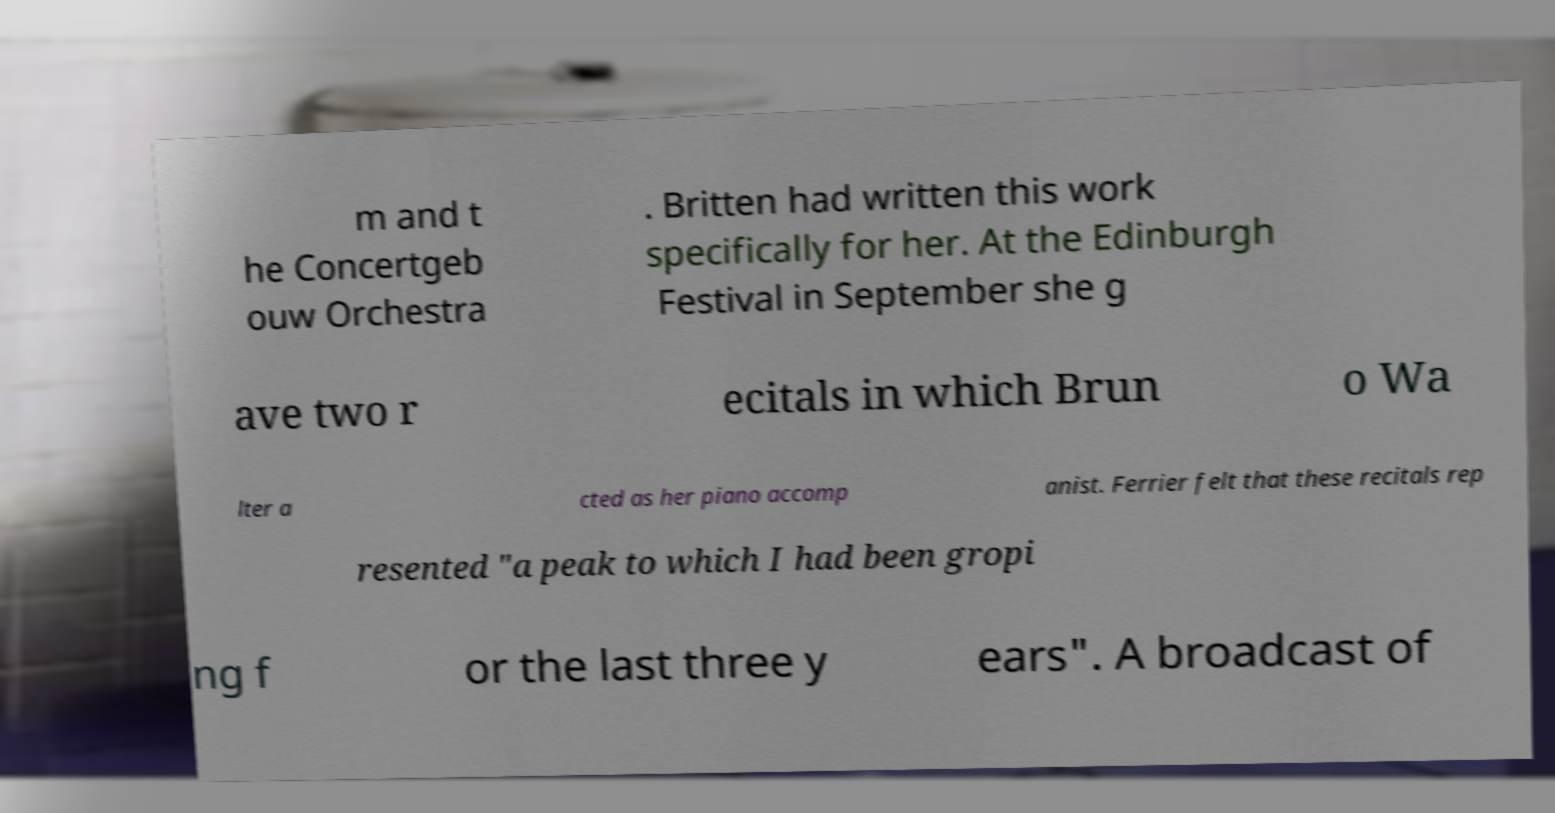Could you extract and type out the text from this image? m and t he Concertgeb ouw Orchestra . Britten had written this work specifically for her. At the Edinburgh Festival in September she g ave two r ecitals in which Brun o Wa lter a cted as her piano accomp anist. Ferrier felt that these recitals rep resented "a peak to which I had been gropi ng f or the last three y ears". A broadcast of 